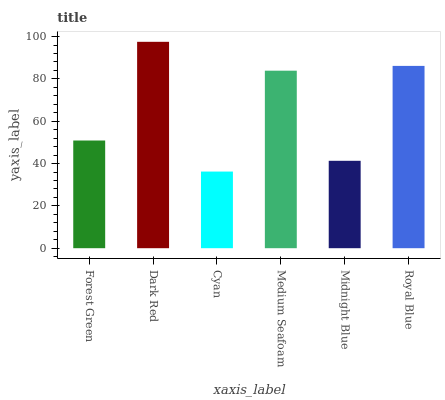Is Dark Red the minimum?
Answer yes or no. No. Is Cyan the maximum?
Answer yes or no. No. Is Dark Red greater than Cyan?
Answer yes or no. Yes. Is Cyan less than Dark Red?
Answer yes or no. Yes. Is Cyan greater than Dark Red?
Answer yes or no. No. Is Dark Red less than Cyan?
Answer yes or no. No. Is Medium Seafoam the high median?
Answer yes or no. Yes. Is Forest Green the low median?
Answer yes or no. Yes. Is Midnight Blue the high median?
Answer yes or no. No. Is Medium Seafoam the low median?
Answer yes or no. No. 